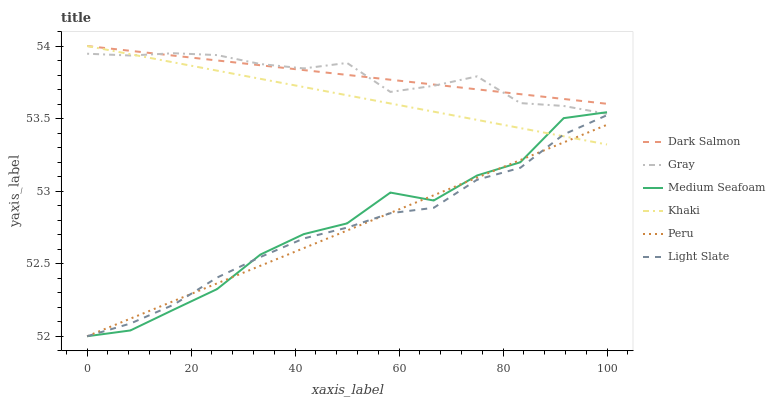Does Khaki have the minimum area under the curve?
Answer yes or no. No. Does Khaki have the maximum area under the curve?
Answer yes or no. No. Is Light Slate the smoothest?
Answer yes or no. No. Is Light Slate the roughest?
Answer yes or no. No. Does Khaki have the lowest value?
Answer yes or no. No. Does Light Slate have the highest value?
Answer yes or no. No. Is Peru less than Gray?
Answer yes or no. Yes. Is Gray greater than Peru?
Answer yes or no. Yes. Does Peru intersect Gray?
Answer yes or no. No. 